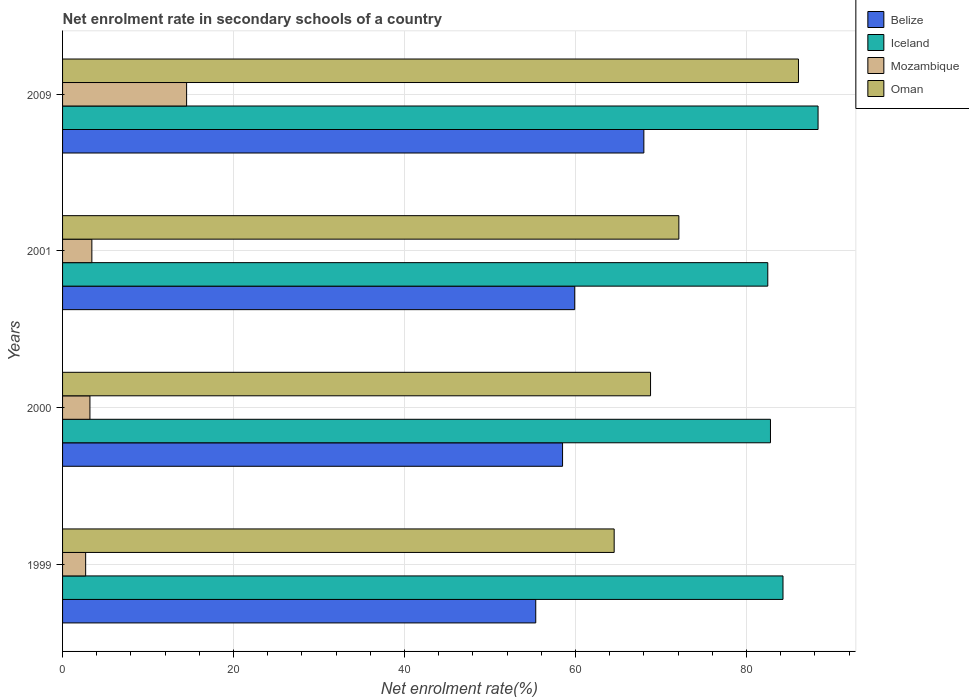How many different coloured bars are there?
Ensure brevity in your answer.  4. How many groups of bars are there?
Give a very brief answer. 4. Are the number of bars per tick equal to the number of legend labels?
Offer a terse response. Yes. Are the number of bars on each tick of the Y-axis equal?
Give a very brief answer. Yes. How many bars are there on the 3rd tick from the top?
Provide a succinct answer. 4. In how many cases, is the number of bars for a given year not equal to the number of legend labels?
Provide a succinct answer. 0. What is the net enrolment rate in secondary schools in Iceland in 2001?
Make the answer very short. 82.49. Across all years, what is the maximum net enrolment rate in secondary schools in Oman?
Make the answer very short. 86.08. Across all years, what is the minimum net enrolment rate in secondary schools in Belize?
Make the answer very short. 55.35. In which year was the net enrolment rate in secondary schools in Oman maximum?
Your answer should be very brief. 2009. In which year was the net enrolment rate in secondary schools in Mozambique minimum?
Your answer should be very brief. 1999. What is the total net enrolment rate in secondary schools in Mozambique in the graph?
Your answer should be compact. 23.84. What is the difference between the net enrolment rate in secondary schools in Oman in 1999 and that in 2009?
Offer a very short reply. -21.56. What is the difference between the net enrolment rate in secondary schools in Mozambique in 2009 and the net enrolment rate in secondary schools in Belize in 2001?
Give a very brief answer. -45.39. What is the average net enrolment rate in secondary schools in Iceland per year?
Provide a succinct answer. 84.48. In the year 1999, what is the difference between the net enrolment rate in secondary schools in Mozambique and net enrolment rate in secondary schools in Iceland?
Your response must be concise. -81.57. In how many years, is the net enrolment rate in secondary schools in Belize greater than 24 %?
Ensure brevity in your answer.  4. What is the ratio of the net enrolment rate in secondary schools in Oman in 2000 to that in 2009?
Offer a very short reply. 0.8. Is the difference between the net enrolment rate in secondary schools in Mozambique in 1999 and 2001 greater than the difference between the net enrolment rate in secondary schools in Iceland in 1999 and 2001?
Ensure brevity in your answer.  No. What is the difference between the highest and the second highest net enrolment rate in secondary schools in Belize?
Your response must be concise. 8.09. What is the difference between the highest and the lowest net enrolment rate in secondary schools in Oman?
Provide a short and direct response. 21.56. Is the sum of the net enrolment rate in secondary schools in Iceland in 1999 and 2009 greater than the maximum net enrolment rate in secondary schools in Belize across all years?
Offer a very short reply. Yes. Is it the case that in every year, the sum of the net enrolment rate in secondary schools in Mozambique and net enrolment rate in secondary schools in Iceland is greater than the sum of net enrolment rate in secondary schools in Belize and net enrolment rate in secondary schools in Oman?
Ensure brevity in your answer.  No. What does the 2nd bar from the top in 2001 represents?
Your response must be concise. Mozambique. What does the 4th bar from the bottom in 1999 represents?
Keep it short and to the point. Oman. How many bars are there?
Make the answer very short. 16. How many years are there in the graph?
Ensure brevity in your answer.  4. What is the difference between two consecutive major ticks on the X-axis?
Offer a very short reply. 20. Are the values on the major ticks of X-axis written in scientific E-notation?
Provide a short and direct response. No. How are the legend labels stacked?
Offer a very short reply. Vertical. What is the title of the graph?
Your answer should be compact. Net enrolment rate in secondary schools of a country. Does "Djibouti" appear as one of the legend labels in the graph?
Make the answer very short. No. What is the label or title of the X-axis?
Make the answer very short. Net enrolment rate(%). What is the Net enrolment rate(%) in Belize in 1999?
Your answer should be compact. 55.35. What is the Net enrolment rate(%) of Iceland in 1999?
Ensure brevity in your answer.  84.27. What is the Net enrolment rate(%) in Mozambique in 1999?
Make the answer very short. 2.7. What is the Net enrolment rate(%) of Oman in 1999?
Your answer should be very brief. 64.52. What is the Net enrolment rate(%) of Belize in 2000?
Provide a succinct answer. 58.48. What is the Net enrolment rate(%) in Iceland in 2000?
Keep it short and to the point. 82.8. What is the Net enrolment rate(%) in Mozambique in 2000?
Give a very brief answer. 3.2. What is the Net enrolment rate(%) in Oman in 2000?
Ensure brevity in your answer.  68.77. What is the Net enrolment rate(%) of Belize in 2001?
Offer a terse response. 59.9. What is the Net enrolment rate(%) in Iceland in 2001?
Ensure brevity in your answer.  82.49. What is the Net enrolment rate(%) of Mozambique in 2001?
Ensure brevity in your answer.  3.43. What is the Net enrolment rate(%) in Oman in 2001?
Ensure brevity in your answer.  72.09. What is the Net enrolment rate(%) in Belize in 2009?
Provide a short and direct response. 67.99. What is the Net enrolment rate(%) in Iceland in 2009?
Offer a terse response. 88.37. What is the Net enrolment rate(%) in Mozambique in 2009?
Your response must be concise. 14.51. What is the Net enrolment rate(%) in Oman in 2009?
Offer a very short reply. 86.08. Across all years, what is the maximum Net enrolment rate(%) of Belize?
Provide a succinct answer. 67.99. Across all years, what is the maximum Net enrolment rate(%) in Iceland?
Your answer should be very brief. 88.37. Across all years, what is the maximum Net enrolment rate(%) in Mozambique?
Keep it short and to the point. 14.51. Across all years, what is the maximum Net enrolment rate(%) in Oman?
Give a very brief answer. 86.08. Across all years, what is the minimum Net enrolment rate(%) of Belize?
Your answer should be compact. 55.35. Across all years, what is the minimum Net enrolment rate(%) in Iceland?
Provide a short and direct response. 82.49. Across all years, what is the minimum Net enrolment rate(%) of Mozambique?
Make the answer very short. 2.7. Across all years, what is the minimum Net enrolment rate(%) of Oman?
Provide a short and direct response. 64.52. What is the total Net enrolment rate(%) of Belize in the graph?
Make the answer very short. 241.72. What is the total Net enrolment rate(%) in Iceland in the graph?
Keep it short and to the point. 337.92. What is the total Net enrolment rate(%) in Mozambique in the graph?
Provide a succinct answer. 23.84. What is the total Net enrolment rate(%) in Oman in the graph?
Make the answer very short. 291.45. What is the difference between the Net enrolment rate(%) of Belize in 1999 and that in 2000?
Offer a very short reply. -3.14. What is the difference between the Net enrolment rate(%) in Iceland in 1999 and that in 2000?
Keep it short and to the point. 1.47. What is the difference between the Net enrolment rate(%) in Mozambique in 1999 and that in 2000?
Give a very brief answer. -0.5. What is the difference between the Net enrolment rate(%) in Oman in 1999 and that in 2000?
Provide a short and direct response. -4.25. What is the difference between the Net enrolment rate(%) of Belize in 1999 and that in 2001?
Make the answer very short. -4.56. What is the difference between the Net enrolment rate(%) of Iceland in 1999 and that in 2001?
Your response must be concise. 1.78. What is the difference between the Net enrolment rate(%) of Mozambique in 1999 and that in 2001?
Offer a very short reply. -0.73. What is the difference between the Net enrolment rate(%) of Oman in 1999 and that in 2001?
Keep it short and to the point. -7.57. What is the difference between the Net enrolment rate(%) of Belize in 1999 and that in 2009?
Your answer should be very brief. -12.64. What is the difference between the Net enrolment rate(%) of Iceland in 1999 and that in 2009?
Your answer should be very brief. -4.1. What is the difference between the Net enrolment rate(%) of Mozambique in 1999 and that in 2009?
Provide a succinct answer. -11.81. What is the difference between the Net enrolment rate(%) of Oman in 1999 and that in 2009?
Your answer should be very brief. -21.56. What is the difference between the Net enrolment rate(%) in Belize in 2000 and that in 2001?
Keep it short and to the point. -1.42. What is the difference between the Net enrolment rate(%) in Iceland in 2000 and that in 2001?
Offer a very short reply. 0.31. What is the difference between the Net enrolment rate(%) of Mozambique in 2000 and that in 2001?
Your answer should be very brief. -0.22. What is the difference between the Net enrolment rate(%) in Oman in 2000 and that in 2001?
Give a very brief answer. -3.31. What is the difference between the Net enrolment rate(%) in Belize in 2000 and that in 2009?
Your answer should be compact. -9.51. What is the difference between the Net enrolment rate(%) in Iceland in 2000 and that in 2009?
Your answer should be very brief. -5.57. What is the difference between the Net enrolment rate(%) of Mozambique in 2000 and that in 2009?
Provide a succinct answer. -11.31. What is the difference between the Net enrolment rate(%) in Oman in 2000 and that in 2009?
Keep it short and to the point. -17.3. What is the difference between the Net enrolment rate(%) of Belize in 2001 and that in 2009?
Offer a terse response. -8.09. What is the difference between the Net enrolment rate(%) of Iceland in 2001 and that in 2009?
Your response must be concise. -5.88. What is the difference between the Net enrolment rate(%) in Mozambique in 2001 and that in 2009?
Keep it short and to the point. -11.08. What is the difference between the Net enrolment rate(%) in Oman in 2001 and that in 2009?
Your response must be concise. -13.99. What is the difference between the Net enrolment rate(%) of Belize in 1999 and the Net enrolment rate(%) of Iceland in 2000?
Offer a terse response. -27.45. What is the difference between the Net enrolment rate(%) in Belize in 1999 and the Net enrolment rate(%) in Mozambique in 2000?
Your answer should be compact. 52.14. What is the difference between the Net enrolment rate(%) in Belize in 1999 and the Net enrolment rate(%) in Oman in 2000?
Provide a succinct answer. -13.43. What is the difference between the Net enrolment rate(%) in Iceland in 1999 and the Net enrolment rate(%) in Mozambique in 2000?
Keep it short and to the point. 81.06. What is the difference between the Net enrolment rate(%) in Iceland in 1999 and the Net enrolment rate(%) in Oman in 2000?
Your answer should be compact. 15.49. What is the difference between the Net enrolment rate(%) in Mozambique in 1999 and the Net enrolment rate(%) in Oman in 2000?
Offer a terse response. -66.07. What is the difference between the Net enrolment rate(%) in Belize in 1999 and the Net enrolment rate(%) in Iceland in 2001?
Keep it short and to the point. -27.14. What is the difference between the Net enrolment rate(%) in Belize in 1999 and the Net enrolment rate(%) in Mozambique in 2001?
Keep it short and to the point. 51.92. What is the difference between the Net enrolment rate(%) in Belize in 1999 and the Net enrolment rate(%) in Oman in 2001?
Give a very brief answer. -16.74. What is the difference between the Net enrolment rate(%) in Iceland in 1999 and the Net enrolment rate(%) in Mozambique in 2001?
Give a very brief answer. 80.84. What is the difference between the Net enrolment rate(%) of Iceland in 1999 and the Net enrolment rate(%) of Oman in 2001?
Give a very brief answer. 12.18. What is the difference between the Net enrolment rate(%) of Mozambique in 1999 and the Net enrolment rate(%) of Oman in 2001?
Provide a succinct answer. -69.38. What is the difference between the Net enrolment rate(%) in Belize in 1999 and the Net enrolment rate(%) in Iceland in 2009?
Keep it short and to the point. -33.02. What is the difference between the Net enrolment rate(%) of Belize in 1999 and the Net enrolment rate(%) of Mozambique in 2009?
Your response must be concise. 40.84. What is the difference between the Net enrolment rate(%) of Belize in 1999 and the Net enrolment rate(%) of Oman in 2009?
Your response must be concise. -30.73. What is the difference between the Net enrolment rate(%) of Iceland in 1999 and the Net enrolment rate(%) of Mozambique in 2009?
Offer a terse response. 69.76. What is the difference between the Net enrolment rate(%) in Iceland in 1999 and the Net enrolment rate(%) in Oman in 2009?
Your answer should be very brief. -1.81. What is the difference between the Net enrolment rate(%) of Mozambique in 1999 and the Net enrolment rate(%) of Oman in 2009?
Make the answer very short. -83.37. What is the difference between the Net enrolment rate(%) in Belize in 2000 and the Net enrolment rate(%) in Iceland in 2001?
Your response must be concise. -24. What is the difference between the Net enrolment rate(%) of Belize in 2000 and the Net enrolment rate(%) of Mozambique in 2001?
Ensure brevity in your answer.  55.06. What is the difference between the Net enrolment rate(%) of Belize in 2000 and the Net enrolment rate(%) of Oman in 2001?
Your response must be concise. -13.6. What is the difference between the Net enrolment rate(%) of Iceland in 2000 and the Net enrolment rate(%) of Mozambique in 2001?
Offer a very short reply. 79.37. What is the difference between the Net enrolment rate(%) in Iceland in 2000 and the Net enrolment rate(%) in Oman in 2001?
Make the answer very short. 10.71. What is the difference between the Net enrolment rate(%) of Mozambique in 2000 and the Net enrolment rate(%) of Oman in 2001?
Offer a very short reply. -68.88. What is the difference between the Net enrolment rate(%) of Belize in 2000 and the Net enrolment rate(%) of Iceland in 2009?
Your response must be concise. -29.88. What is the difference between the Net enrolment rate(%) in Belize in 2000 and the Net enrolment rate(%) in Mozambique in 2009?
Offer a terse response. 43.97. What is the difference between the Net enrolment rate(%) in Belize in 2000 and the Net enrolment rate(%) in Oman in 2009?
Your answer should be compact. -27.59. What is the difference between the Net enrolment rate(%) in Iceland in 2000 and the Net enrolment rate(%) in Mozambique in 2009?
Provide a succinct answer. 68.29. What is the difference between the Net enrolment rate(%) in Iceland in 2000 and the Net enrolment rate(%) in Oman in 2009?
Make the answer very short. -3.28. What is the difference between the Net enrolment rate(%) in Mozambique in 2000 and the Net enrolment rate(%) in Oman in 2009?
Your answer should be very brief. -82.87. What is the difference between the Net enrolment rate(%) of Belize in 2001 and the Net enrolment rate(%) of Iceland in 2009?
Provide a succinct answer. -28.46. What is the difference between the Net enrolment rate(%) of Belize in 2001 and the Net enrolment rate(%) of Mozambique in 2009?
Make the answer very short. 45.39. What is the difference between the Net enrolment rate(%) in Belize in 2001 and the Net enrolment rate(%) in Oman in 2009?
Ensure brevity in your answer.  -26.17. What is the difference between the Net enrolment rate(%) of Iceland in 2001 and the Net enrolment rate(%) of Mozambique in 2009?
Make the answer very short. 67.98. What is the difference between the Net enrolment rate(%) of Iceland in 2001 and the Net enrolment rate(%) of Oman in 2009?
Your response must be concise. -3.59. What is the difference between the Net enrolment rate(%) in Mozambique in 2001 and the Net enrolment rate(%) in Oman in 2009?
Provide a short and direct response. -82.65. What is the average Net enrolment rate(%) in Belize per year?
Provide a succinct answer. 60.43. What is the average Net enrolment rate(%) in Iceland per year?
Provide a succinct answer. 84.48. What is the average Net enrolment rate(%) in Mozambique per year?
Provide a succinct answer. 5.96. What is the average Net enrolment rate(%) of Oman per year?
Your answer should be very brief. 72.86. In the year 1999, what is the difference between the Net enrolment rate(%) of Belize and Net enrolment rate(%) of Iceland?
Keep it short and to the point. -28.92. In the year 1999, what is the difference between the Net enrolment rate(%) in Belize and Net enrolment rate(%) in Mozambique?
Your response must be concise. 52.64. In the year 1999, what is the difference between the Net enrolment rate(%) in Belize and Net enrolment rate(%) in Oman?
Keep it short and to the point. -9.17. In the year 1999, what is the difference between the Net enrolment rate(%) in Iceland and Net enrolment rate(%) in Mozambique?
Keep it short and to the point. 81.56. In the year 1999, what is the difference between the Net enrolment rate(%) of Iceland and Net enrolment rate(%) of Oman?
Your response must be concise. 19.75. In the year 1999, what is the difference between the Net enrolment rate(%) of Mozambique and Net enrolment rate(%) of Oman?
Make the answer very short. -61.82. In the year 2000, what is the difference between the Net enrolment rate(%) in Belize and Net enrolment rate(%) in Iceland?
Ensure brevity in your answer.  -24.32. In the year 2000, what is the difference between the Net enrolment rate(%) of Belize and Net enrolment rate(%) of Mozambique?
Give a very brief answer. 55.28. In the year 2000, what is the difference between the Net enrolment rate(%) in Belize and Net enrolment rate(%) in Oman?
Your answer should be compact. -10.29. In the year 2000, what is the difference between the Net enrolment rate(%) in Iceland and Net enrolment rate(%) in Mozambique?
Offer a terse response. 79.6. In the year 2000, what is the difference between the Net enrolment rate(%) in Iceland and Net enrolment rate(%) in Oman?
Ensure brevity in your answer.  14.03. In the year 2000, what is the difference between the Net enrolment rate(%) of Mozambique and Net enrolment rate(%) of Oman?
Your answer should be compact. -65.57. In the year 2001, what is the difference between the Net enrolment rate(%) in Belize and Net enrolment rate(%) in Iceland?
Your response must be concise. -22.58. In the year 2001, what is the difference between the Net enrolment rate(%) in Belize and Net enrolment rate(%) in Mozambique?
Make the answer very short. 56.48. In the year 2001, what is the difference between the Net enrolment rate(%) of Belize and Net enrolment rate(%) of Oman?
Make the answer very short. -12.18. In the year 2001, what is the difference between the Net enrolment rate(%) in Iceland and Net enrolment rate(%) in Mozambique?
Keep it short and to the point. 79.06. In the year 2001, what is the difference between the Net enrolment rate(%) in Iceland and Net enrolment rate(%) in Oman?
Keep it short and to the point. 10.4. In the year 2001, what is the difference between the Net enrolment rate(%) of Mozambique and Net enrolment rate(%) of Oman?
Your answer should be compact. -68.66. In the year 2009, what is the difference between the Net enrolment rate(%) in Belize and Net enrolment rate(%) in Iceland?
Ensure brevity in your answer.  -20.38. In the year 2009, what is the difference between the Net enrolment rate(%) in Belize and Net enrolment rate(%) in Mozambique?
Provide a short and direct response. 53.48. In the year 2009, what is the difference between the Net enrolment rate(%) in Belize and Net enrolment rate(%) in Oman?
Ensure brevity in your answer.  -18.09. In the year 2009, what is the difference between the Net enrolment rate(%) of Iceland and Net enrolment rate(%) of Mozambique?
Your answer should be very brief. 73.86. In the year 2009, what is the difference between the Net enrolment rate(%) in Iceland and Net enrolment rate(%) in Oman?
Make the answer very short. 2.29. In the year 2009, what is the difference between the Net enrolment rate(%) of Mozambique and Net enrolment rate(%) of Oman?
Your response must be concise. -71.57. What is the ratio of the Net enrolment rate(%) in Belize in 1999 to that in 2000?
Make the answer very short. 0.95. What is the ratio of the Net enrolment rate(%) of Iceland in 1999 to that in 2000?
Offer a terse response. 1.02. What is the ratio of the Net enrolment rate(%) in Mozambique in 1999 to that in 2000?
Provide a short and direct response. 0.84. What is the ratio of the Net enrolment rate(%) in Oman in 1999 to that in 2000?
Offer a very short reply. 0.94. What is the ratio of the Net enrolment rate(%) of Belize in 1999 to that in 2001?
Provide a succinct answer. 0.92. What is the ratio of the Net enrolment rate(%) in Iceland in 1999 to that in 2001?
Ensure brevity in your answer.  1.02. What is the ratio of the Net enrolment rate(%) of Mozambique in 1999 to that in 2001?
Make the answer very short. 0.79. What is the ratio of the Net enrolment rate(%) in Oman in 1999 to that in 2001?
Offer a very short reply. 0.9. What is the ratio of the Net enrolment rate(%) of Belize in 1999 to that in 2009?
Your response must be concise. 0.81. What is the ratio of the Net enrolment rate(%) of Iceland in 1999 to that in 2009?
Provide a short and direct response. 0.95. What is the ratio of the Net enrolment rate(%) of Mozambique in 1999 to that in 2009?
Provide a succinct answer. 0.19. What is the ratio of the Net enrolment rate(%) in Oman in 1999 to that in 2009?
Give a very brief answer. 0.75. What is the ratio of the Net enrolment rate(%) of Belize in 2000 to that in 2001?
Offer a very short reply. 0.98. What is the ratio of the Net enrolment rate(%) of Iceland in 2000 to that in 2001?
Make the answer very short. 1. What is the ratio of the Net enrolment rate(%) of Mozambique in 2000 to that in 2001?
Give a very brief answer. 0.93. What is the ratio of the Net enrolment rate(%) of Oman in 2000 to that in 2001?
Offer a very short reply. 0.95. What is the ratio of the Net enrolment rate(%) of Belize in 2000 to that in 2009?
Make the answer very short. 0.86. What is the ratio of the Net enrolment rate(%) in Iceland in 2000 to that in 2009?
Offer a terse response. 0.94. What is the ratio of the Net enrolment rate(%) of Mozambique in 2000 to that in 2009?
Offer a very short reply. 0.22. What is the ratio of the Net enrolment rate(%) in Oman in 2000 to that in 2009?
Provide a succinct answer. 0.8. What is the ratio of the Net enrolment rate(%) in Belize in 2001 to that in 2009?
Offer a terse response. 0.88. What is the ratio of the Net enrolment rate(%) of Iceland in 2001 to that in 2009?
Your answer should be compact. 0.93. What is the ratio of the Net enrolment rate(%) of Mozambique in 2001 to that in 2009?
Your answer should be compact. 0.24. What is the ratio of the Net enrolment rate(%) in Oman in 2001 to that in 2009?
Your answer should be compact. 0.84. What is the difference between the highest and the second highest Net enrolment rate(%) of Belize?
Ensure brevity in your answer.  8.09. What is the difference between the highest and the second highest Net enrolment rate(%) of Iceland?
Make the answer very short. 4.1. What is the difference between the highest and the second highest Net enrolment rate(%) of Mozambique?
Your answer should be very brief. 11.08. What is the difference between the highest and the second highest Net enrolment rate(%) in Oman?
Give a very brief answer. 13.99. What is the difference between the highest and the lowest Net enrolment rate(%) of Belize?
Offer a terse response. 12.64. What is the difference between the highest and the lowest Net enrolment rate(%) in Iceland?
Your answer should be very brief. 5.88. What is the difference between the highest and the lowest Net enrolment rate(%) of Mozambique?
Offer a very short reply. 11.81. What is the difference between the highest and the lowest Net enrolment rate(%) in Oman?
Provide a succinct answer. 21.56. 